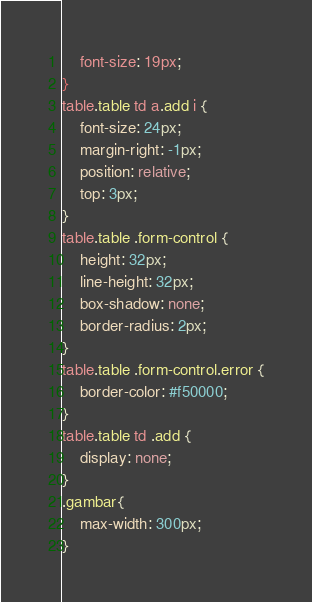<code> <loc_0><loc_0><loc_500><loc_500><_CSS_>    font-size: 19px;
}
table.table td a.add i {
    font-size: 24px;
    margin-right: -1px;
    position: relative;
    top: 3px;
}    
table.table .form-control {
    height: 32px;
    line-height: 32px;
    box-shadow: none;
    border-radius: 2px;
}
table.table .form-control.error {
    border-color: #f50000;
}
table.table td .add {
    display: none;
}
.gambar{
    max-width: 300px;
}</code> 